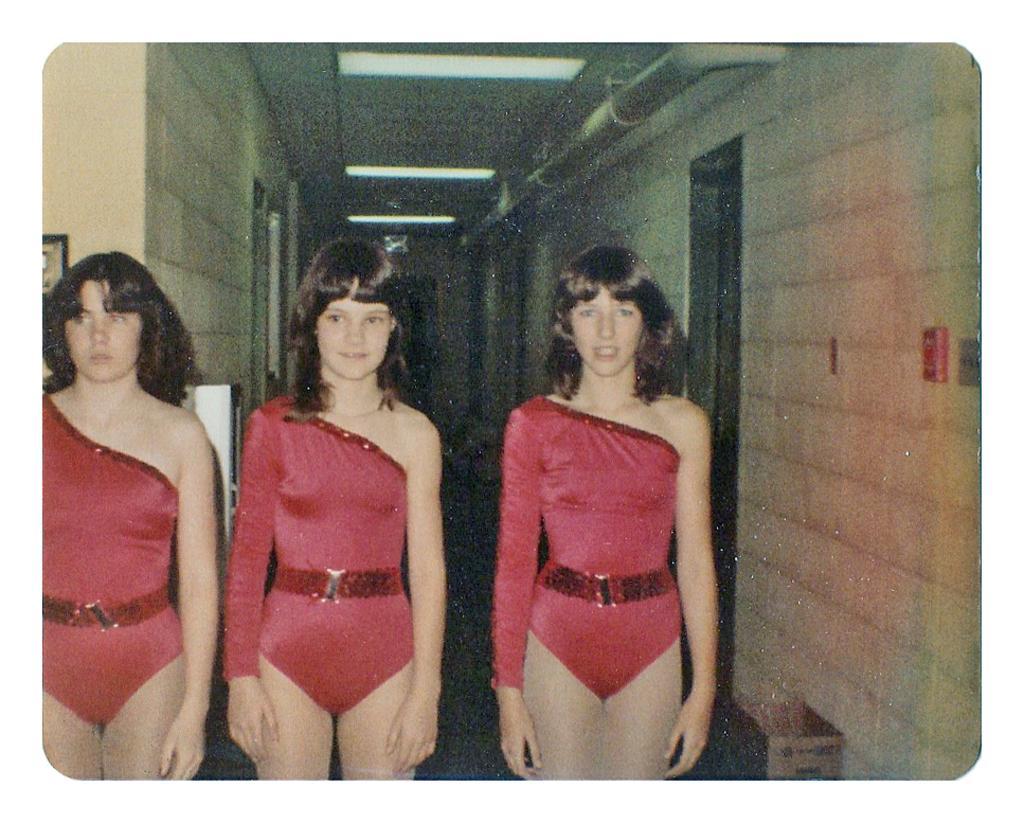Describe this image in one or two sentences. At the bottom of this image, there are three women in red color bikini, smiling and standing. On the right side, there is a wall. In the background, there are lights attached to the roof and there are other objects. 